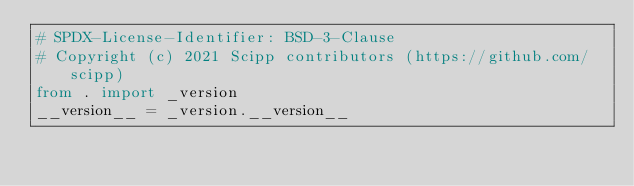<code> <loc_0><loc_0><loc_500><loc_500><_Python_># SPDX-License-Identifier: BSD-3-Clause
# Copyright (c) 2021 Scipp contributors (https://github.com/scipp)
from . import _version
__version__ = _version.__version__
</code> 